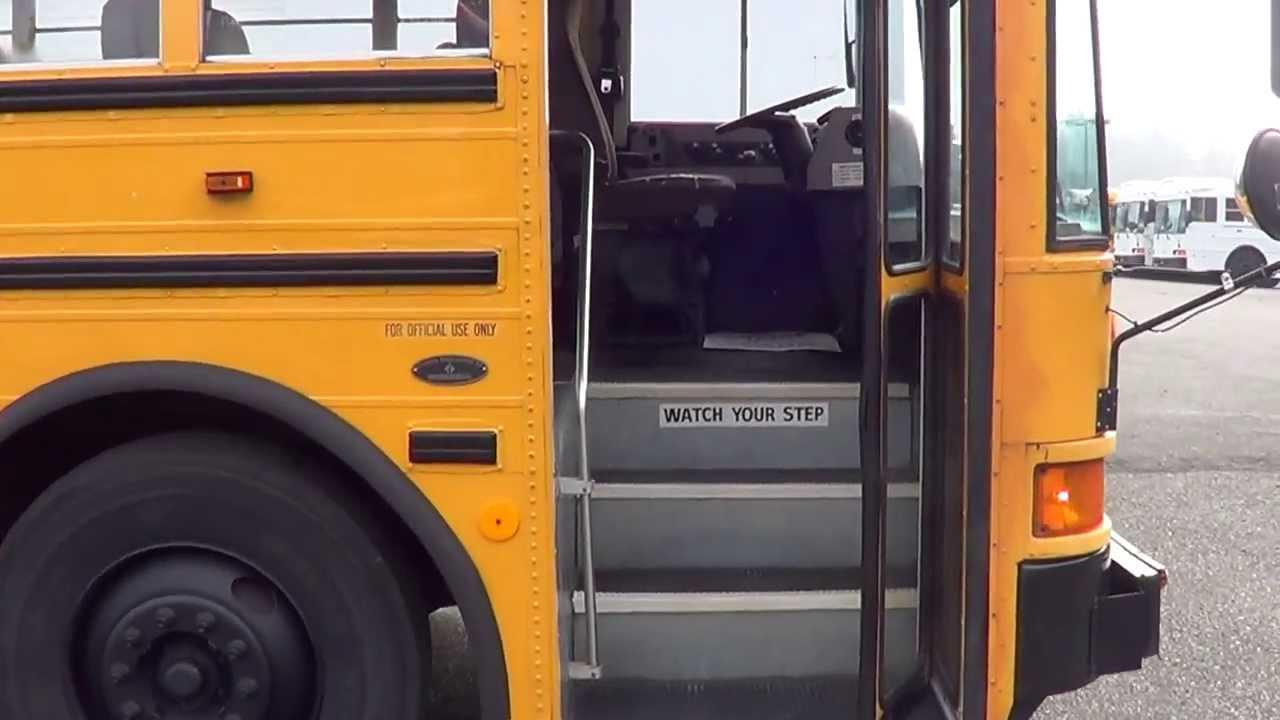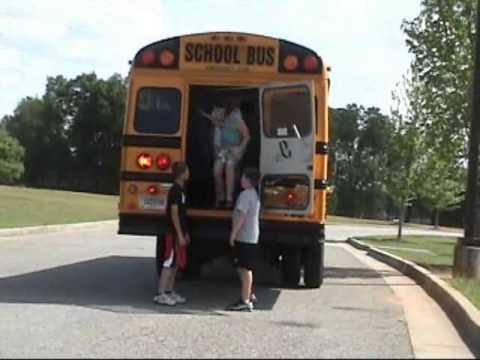The first image is the image on the left, the second image is the image on the right. Evaluate the accuracy of this statement regarding the images: "One of the buses is built with a house door.". Is it true? Answer yes or no. No. The first image is the image on the left, the second image is the image on the right. Assess this claim about the two images: "The lefthand image shows a side-view of a parked yellow bus facing rightward, with its entry door opened.". Correct or not? Answer yes or no. Yes. 